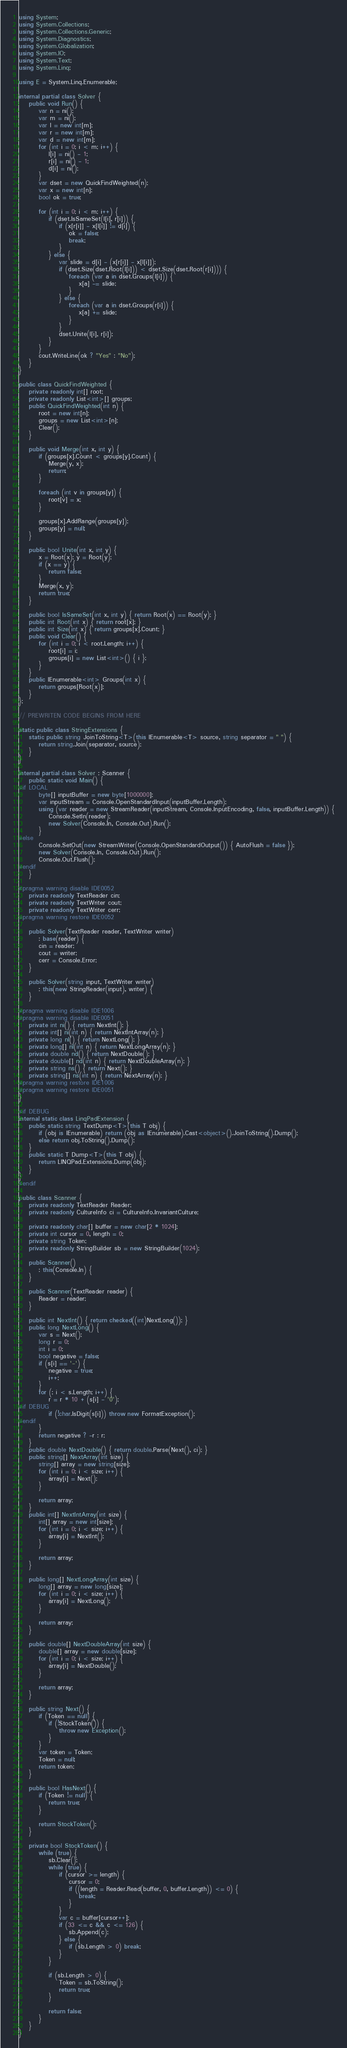<code> <loc_0><loc_0><loc_500><loc_500><_C#_>using System;
using System.Collections;
using System.Collections.Generic;
using System.Diagnostics;
using System.Globalization;
using System.IO;
using System.Text;
using System.Linq;

using E = System.Linq.Enumerable;

internal partial class Solver {
    public void Run() {
        var n = ni();
        var m = ni();
        var l = new int[m];
        var r = new int[m];
        var d = new int[m];
        for (int i = 0; i < m; i++) {
            l[i] = ni() - 1;
            r[i] = ni() - 1;
            d[i] = ni();
        }
        var dset = new QuickFindWeighted(n);
        var x = new int[n];
        bool ok = true;

        for (int i = 0; i < m; i++) {
            if (dset.IsSameSet(l[i], r[i])) {
                if (x[r[i]] - x[l[i]] != d[i]) {
                    ok = false;
                    break;
                }
            } else {
                var slide = d[i] - (x[r[i]] - x[l[i]]);
                if (dset.Size(dset.Root(l[i])) < dset.Size(dset.Root(r[i]))) {
                    foreach (var a in dset.Groups(l[i])) {
                        x[a] -= slide;
                    }
                } else {
                    foreach (var a in dset.Groups(r[i])) {
                        x[a] += slide;
                    }
                }
                dset.Unite(l[i], r[i]);
            }
        }
        cout.WriteLine(ok ? "Yes" : "No");
    }
}

public class QuickFindWeighted {
    private readonly int[] root;
    private readonly List<int>[] groups;
    public QuickFindWeighted(int n) {
        root = new int[n];
        groups = new List<int>[n];
        Clear();
    }

    public void Merge(int x, int y) {
        if (groups[x].Count < groups[y].Count) {
            Merge(y, x);
            return;
        }

        foreach (int v in groups[y]) {
            root[v] = x;
        }

        groups[x].AddRange(groups[y]);
        groups[y] = null;
    }

    public bool Unite(int x, int y) {
        x = Root(x); y = Root(y);
        if (x == y) {
            return false;
        }
        Merge(x, y);
        return true;
    }

    public bool IsSameSet(int x, int y) { return Root(x) == Root(y); }
    public int Root(int x) { return root[x]; }
    public int Size(int x) { return groups[x].Count; }
    public void Clear() {
        for (int i = 0; i < root.Length; i++) {
            root[i] = i;
            groups[i] = new List<int>() { i };
        }
    }
    public IEnumerable<int> Groups(int x) {
        return groups[Root(x)];
    }
};

// PREWRITEN CODE BEGINS FROM HERE

static public class StringExtensions {
    static public string JoinToString<T>(this IEnumerable<T> source, string separator = " ") {
        return string.Join(separator, source);
    }
}

internal partial class Solver : Scanner {
    public static void Main() {
#if LOCAL
        byte[] inputBuffer = new byte[1000000];
        var inputStream = Console.OpenStandardInput(inputBuffer.Length);
        using (var reader = new StreamReader(inputStream, Console.InputEncoding, false, inputBuffer.Length)) {
            Console.SetIn(reader);
            new Solver(Console.In, Console.Out).Run();
        }
#else
        Console.SetOut(new StreamWriter(Console.OpenStandardOutput()) { AutoFlush = false });
        new Solver(Console.In, Console.Out).Run();
        Console.Out.Flush();
#endif
    }

#pragma warning disable IDE0052
    private readonly TextReader cin;
    private readonly TextWriter cout;
    private readonly TextWriter cerr;
#pragma warning restore IDE0052

    public Solver(TextReader reader, TextWriter writer)
        : base(reader) {
        cin = reader;
        cout = writer;
        cerr = Console.Error;
    }

    public Solver(string input, TextWriter writer)
        : this(new StringReader(input), writer) {
    }

#pragma warning disable IDE1006
#pragma warning disable IDE0051
    private int ni() { return NextInt(); }
    private int[] ni(int n) { return NextIntArray(n); }
    private long nl() { return NextLong(); }
    private long[] nl(int n) { return NextLongArray(n); }
    private double nd() { return NextDouble(); }
    private double[] nd(int n) { return NextDoubleArray(n); }
    private string ns() { return Next(); }
    private string[] ns(int n) { return NextArray(n); }
#pragma warning restore IDE1006
#pragma warning restore IDE0051
}

#if DEBUG
internal static class LinqPadExtension {
    public static string TextDump<T>(this T obj) {
        if (obj is IEnumerable) return (obj as IEnumerable).Cast<object>().JoinToString().Dump();
        else return obj.ToString().Dump();
    }
    public static T Dump<T>(this T obj) {
        return LINQPad.Extensions.Dump(obj);
    }
}
#endif

public class Scanner {
    private readonly TextReader Reader;
    private readonly CultureInfo ci = CultureInfo.InvariantCulture;

    private readonly char[] buffer = new char[2 * 1024];
    private int cursor = 0, length = 0;
    private string Token;
    private readonly StringBuilder sb = new StringBuilder(1024);

    public Scanner()
        : this(Console.In) {
    }

    public Scanner(TextReader reader) {
        Reader = reader;
    }

    public int NextInt() { return checked((int)NextLong()); }
    public long NextLong() {
        var s = Next();
        long r = 0;
        int i = 0;
        bool negative = false;
        if (s[i] == '-') {
            negative = true;
            i++;
        }
        for (; i < s.Length; i++) {
            r = r * 10 + (s[i] - '0');
#if DEBUG
            if (!char.IsDigit(s[i])) throw new FormatException();
#endif
        }
        return negative ? -r : r;
    }
    public double NextDouble() { return double.Parse(Next(), ci); }
    public string[] NextArray(int size) {
        string[] array = new string[size];
        for (int i = 0; i < size; i++) {
            array[i] = Next();
        }

        return array;
    }
    public int[] NextIntArray(int size) {
        int[] array = new int[size];
        for (int i = 0; i < size; i++) {
            array[i] = NextInt();
        }

        return array;
    }

    public long[] NextLongArray(int size) {
        long[] array = new long[size];
        for (int i = 0; i < size; i++) {
            array[i] = NextLong();
        }

        return array;
    }

    public double[] NextDoubleArray(int size) {
        double[] array = new double[size];
        for (int i = 0; i < size; i++) {
            array[i] = NextDouble();
        }

        return array;
    }

    public string Next() {
        if (Token == null) {
            if (!StockToken()) {
                throw new Exception();
            }
        }
        var token = Token;
        Token = null;
        return token;
    }

    public bool HasNext() {
        if (Token != null) {
            return true;
        }

        return StockToken();
    }

    private bool StockToken() {
        while (true) {
            sb.Clear();
            while (true) {
                if (cursor >= length) {
                    cursor = 0;
                    if ((length = Reader.Read(buffer, 0, buffer.Length)) <= 0) {
                        break;
                    }
                }
                var c = buffer[cursor++];
                if (33 <= c && c <= 126) {
                    sb.Append(c);
                } else {
                    if (sb.Length > 0) break;
                }
            }

            if (sb.Length > 0) {
                Token = sb.ToString();
                return true;
            }

            return false;
        }
    }
}</code> 